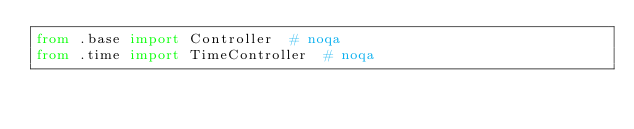Convert code to text. <code><loc_0><loc_0><loc_500><loc_500><_Python_>from .base import Controller  # noqa
from .time import TimeController  # noqa
</code> 